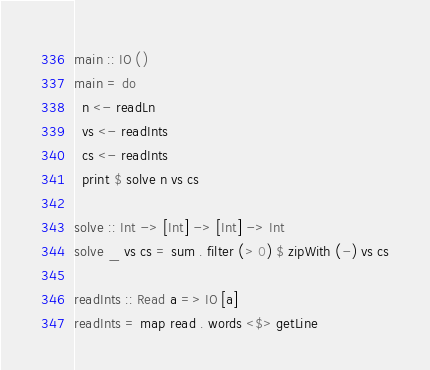Convert code to text. <code><loc_0><loc_0><loc_500><loc_500><_Haskell_>main :: IO ()
main = do
  n <- readLn
  vs <- readInts
  cs <- readInts
  print $ solve n vs cs

solve :: Int -> [Int] -> [Int] -> Int
solve _ vs cs = sum . filter (> 0) $ zipWith (-) vs cs

readInts :: Read a => IO [a]
readInts = map read . words <$> getLine
</code> 